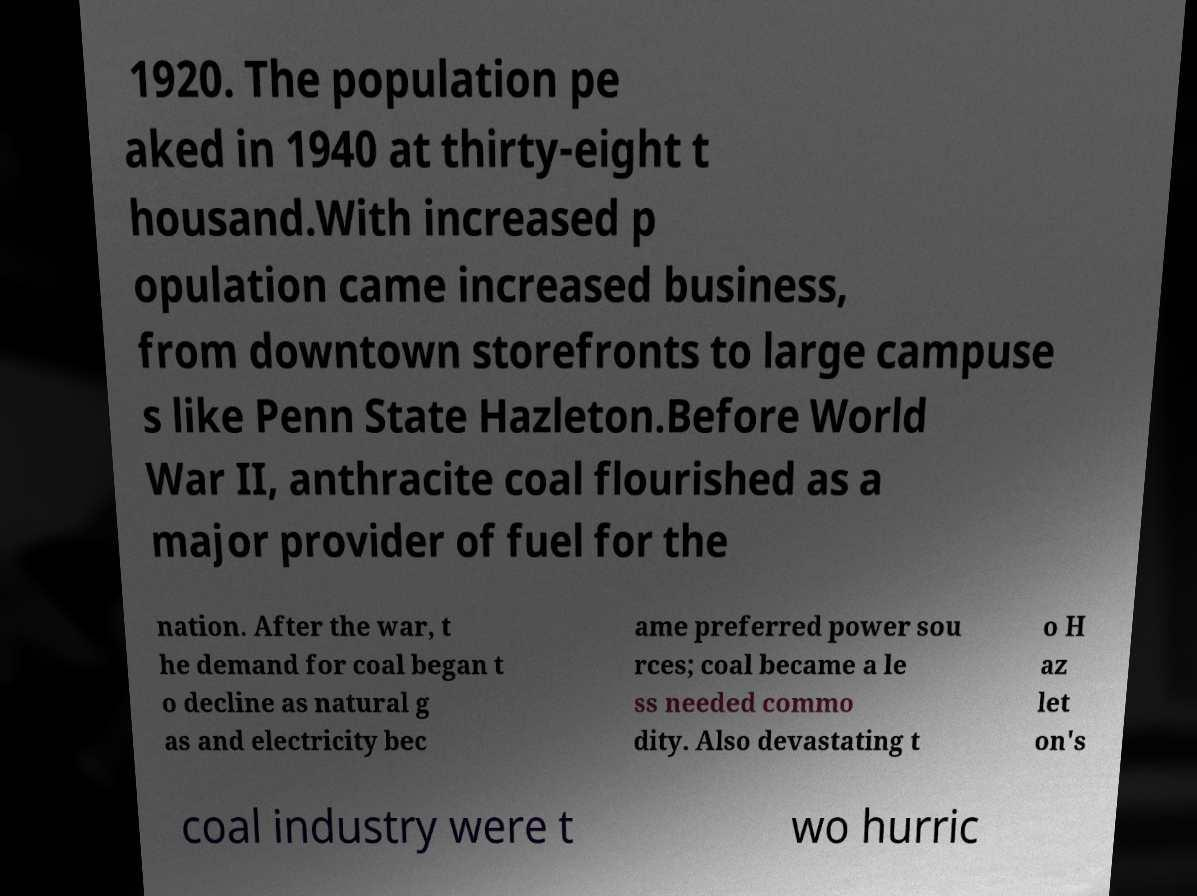Can you read and provide the text displayed in the image?This photo seems to have some interesting text. Can you extract and type it out for me? 1920. The population pe aked in 1940 at thirty-eight t housand.With increased p opulation came increased business, from downtown storefronts to large campuse s like Penn State Hazleton.Before World War II, anthracite coal flourished as a major provider of fuel for the nation. After the war, t he demand for coal began t o decline as natural g as and electricity bec ame preferred power sou rces; coal became a le ss needed commo dity. Also devastating t o H az let on's coal industry were t wo hurric 